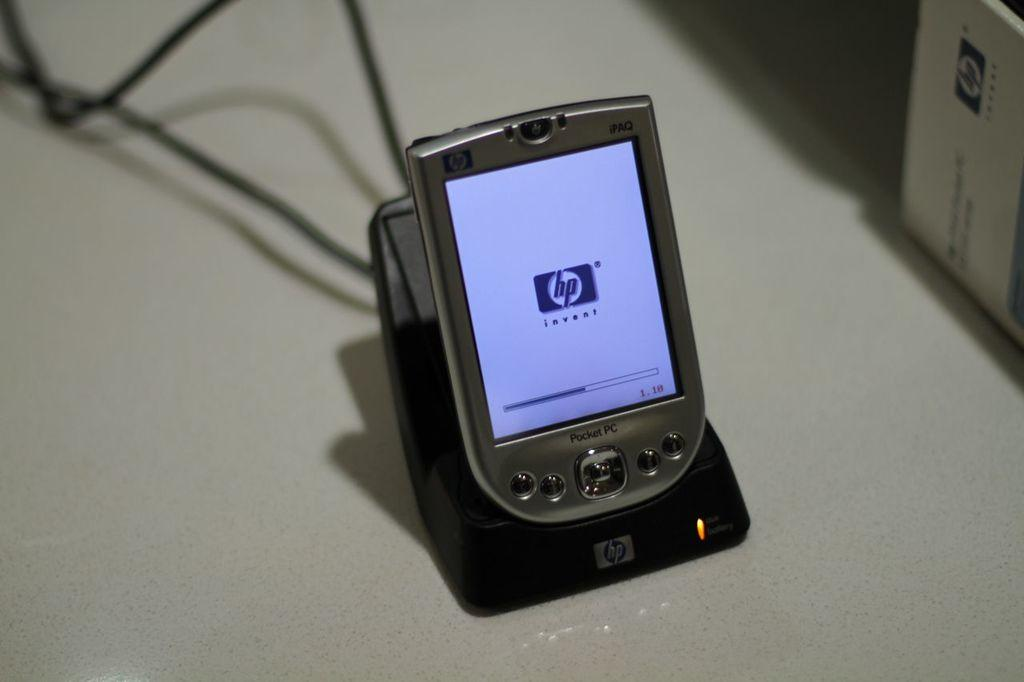<image>
Summarize the visual content of the image. A Hewlitt Packard pocket PC is being charged up. 